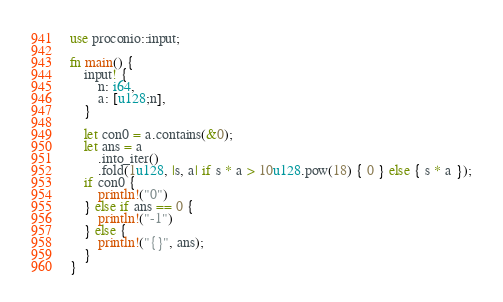Convert code to text. <code><loc_0><loc_0><loc_500><loc_500><_Rust_>use proconio::input;

fn main() {
    input! {
        n: i64,
        a: [u128;n],
    }

    let con0 = a.contains(&0);
    let ans = a
        .into_iter()
        .fold(1u128, |s, a| if s * a > 10u128.pow(18) { 0 } else { s * a });
    if con0 {
        println!("0")
    } else if ans == 0 {
        println!("-1")
    } else {
        println!("{}", ans);
    }
}
</code> 